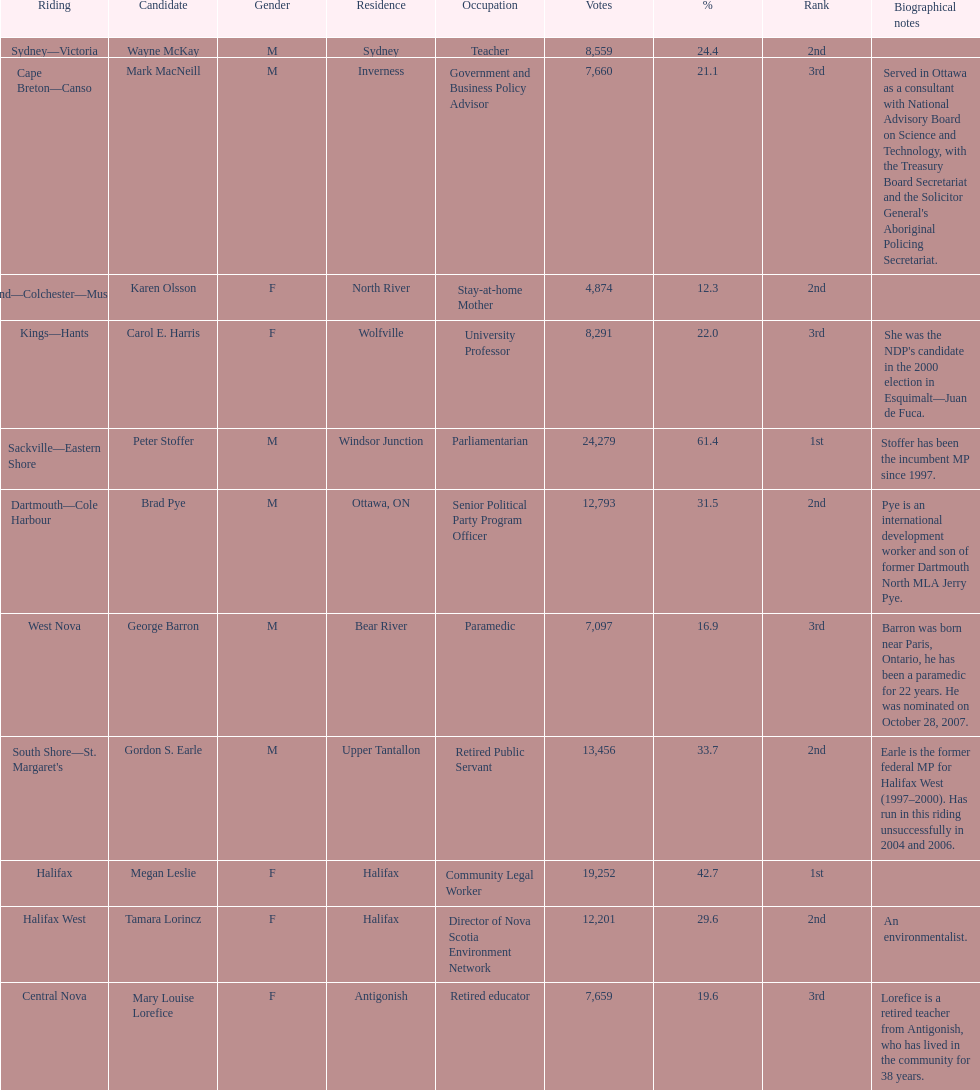Who received the least amount of votes? Karen Olsson. 